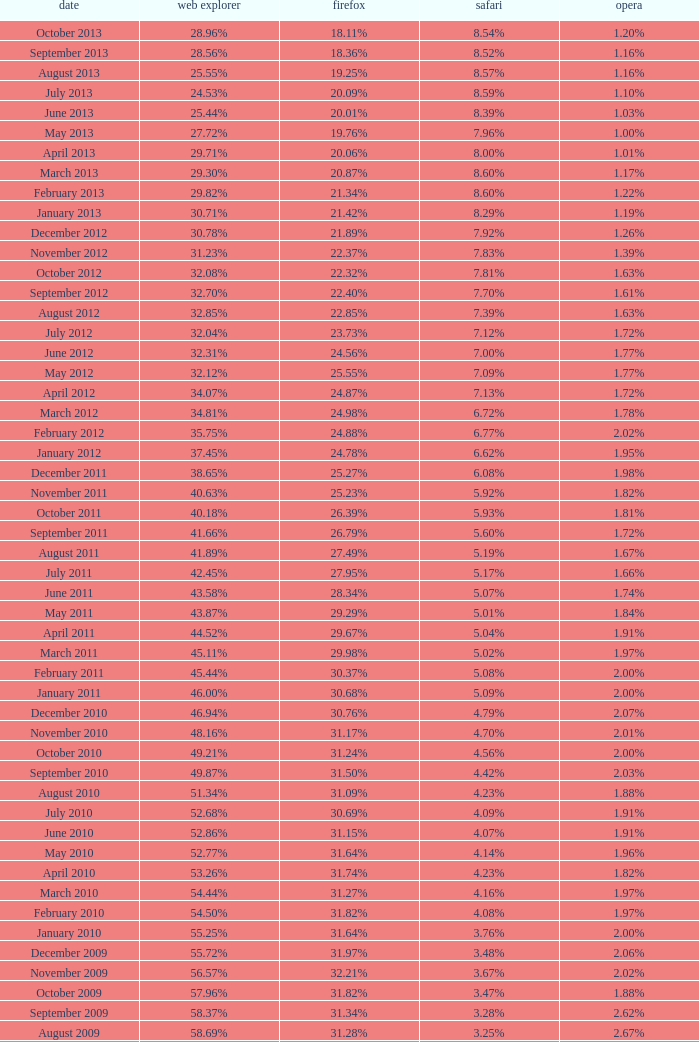What percentage of browsers were using Internet Explorer during the period in which 27.85% were using Firefox? 64.43%. 